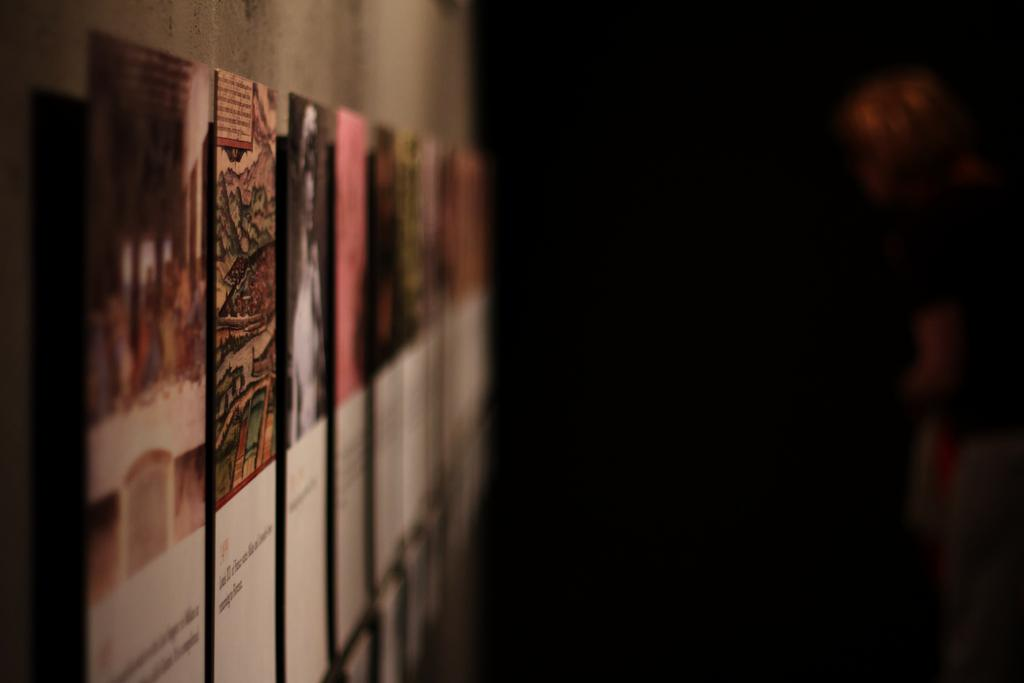What is on the wall on the left side of the image? There are boards on the wall on the left side of the image. What can be observed about the overall lighting in the image? The background of the image is dark. Can you describe the person visible in the background of the image? Unfortunately, the provided facts do not give any details about the person in the background. What type of pump is being used by the person in the middle of the image? There is no person or pump present in the image; it only features boards on the wall and a dark background. How many baseballs can be seen in the image? There are no baseballs present in the image. 